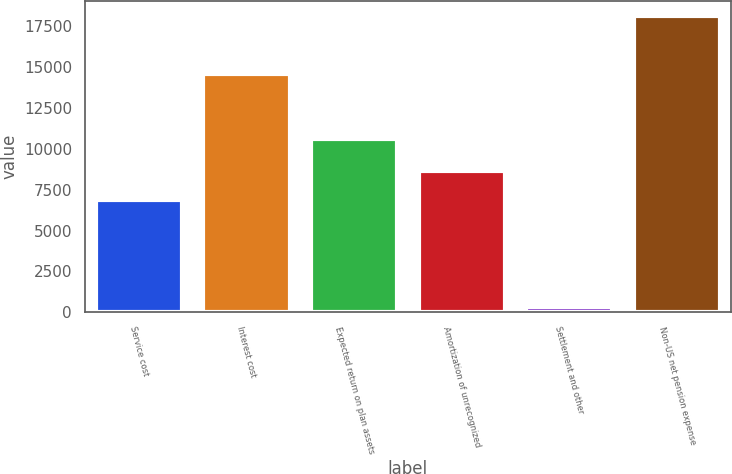Convert chart. <chart><loc_0><loc_0><loc_500><loc_500><bar_chart><fcel>Service cost<fcel>Interest cost<fcel>Expected return on plan assets<fcel>Amortization of unrecognized<fcel>Settlement and other<fcel>Non-US net pension expense<nl><fcel>6857<fcel>14576<fcel>10581<fcel>8638.4<fcel>314<fcel>18128<nl></chart> 